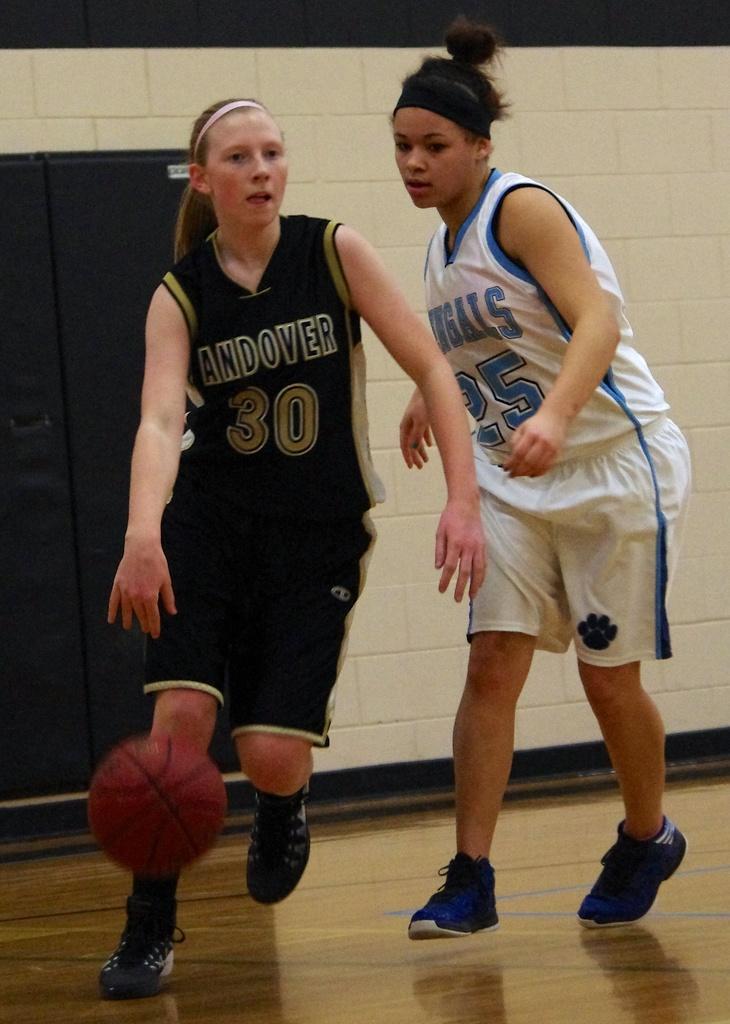What is printed above the number 25 on the player on the right's shirt?
Your response must be concise. Bengals. What is printed above the number 30 on the player on the left's shirt?
Make the answer very short. Andover. 